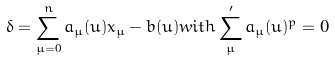<formula> <loc_0><loc_0><loc_500><loc_500>\delta = \sum _ { \mu = 0 } ^ { n } a _ { \mu } ( u ) x _ { \mu } - b ( u ) w i t h \sum _ { \mu } ^ { \prime } a _ { \mu } ( u ) ^ { p } = 0</formula> 